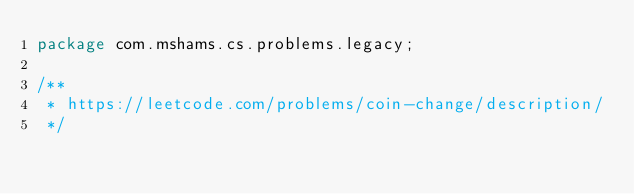Convert code to text. <code><loc_0><loc_0><loc_500><loc_500><_Java_>package com.mshams.cs.problems.legacy;

/**
 * https://leetcode.com/problems/coin-change/description/
 */</code> 